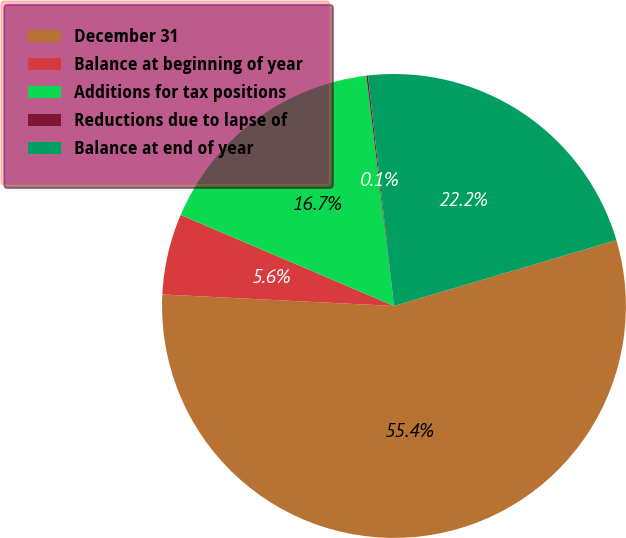<chart> <loc_0><loc_0><loc_500><loc_500><pie_chart><fcel>December 31<fcel>Balance at beginning of year<fcel>Additions for tax positions<fcel>Reductions due to lapse of<fcel>Balance at end of year<nl><fcel>55.36%<fcel>5.63%<fcel>16.68%<fcel>0.11%<fcel>22.21%<nl></chart> 